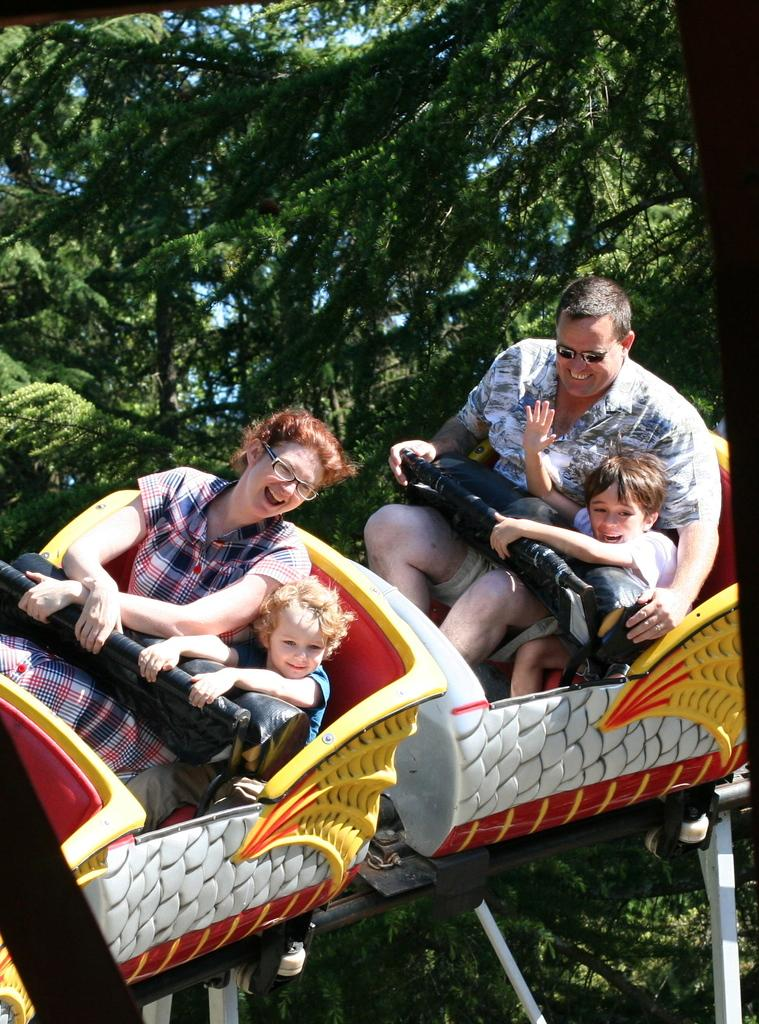How many people are in the image? There are four persons in the image. What are the persons doing in the image? The persons are sitting in a mechanical ride. What is the emotional state of the persons in the image? The persons are smiling in the image. What can be seen in the background of the image? There are trees in the background of the image. What type of silver material is used to make the ice in the image? There is no silver material or ice present in the image. What feeling is being expressed by the persons in the image? The persons are expressing happiness, as they are smiling in the image. 